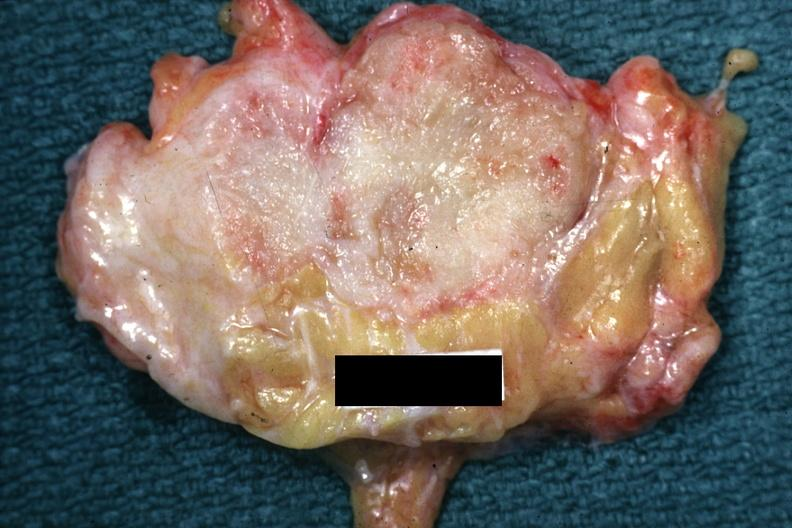what is slide labeled?
Answer the question using a single word or phrase. Labeled cystosarcoma 